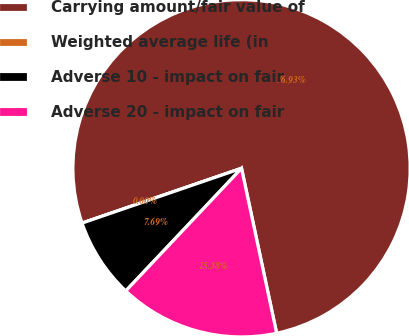<chart> <loc_0><loc_0><loc_500><loc_500><pie_chart><fcel>Carrying amount/fair value of<fcel>Weighted average life (in<fcel>Adverse 10 - impact on fair<fcel>Adverse 20 - impact on fair<nl><fcel>76.92%<fcel>0.0%<fcel>7.69%<fcel>15.38%<nl></chart> 